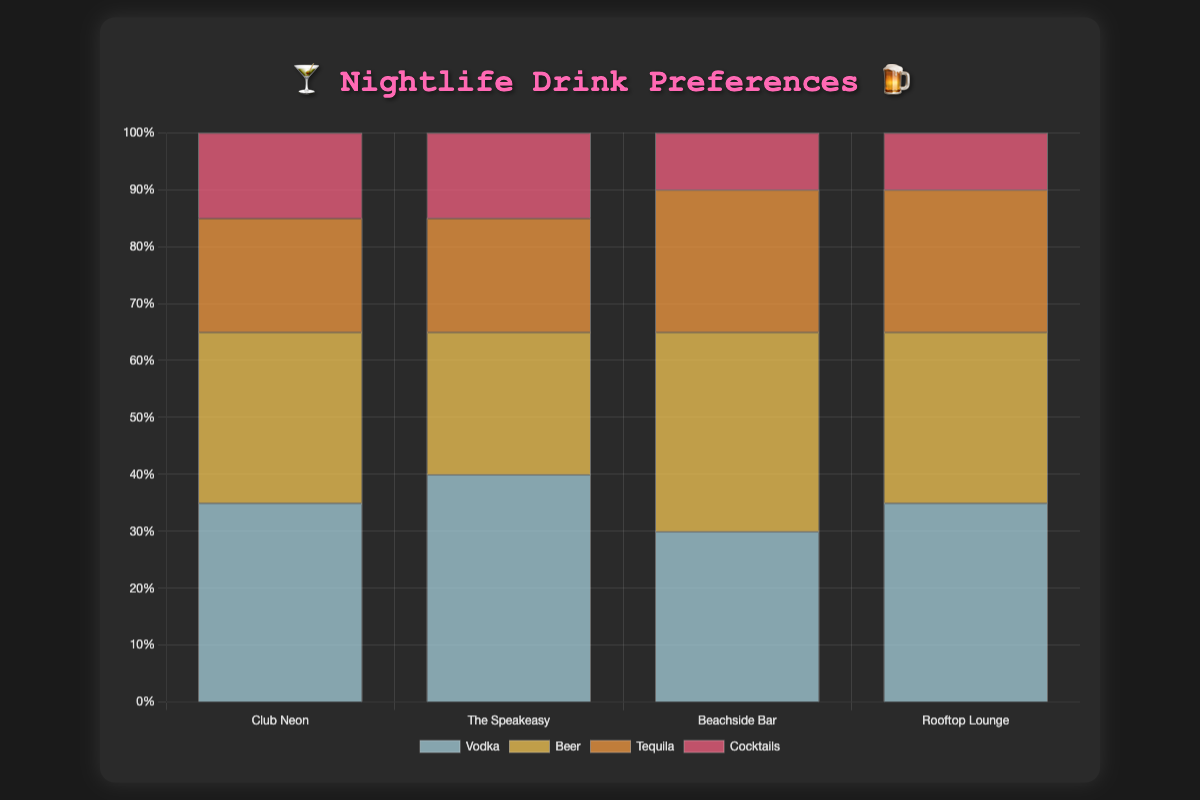What type of drink is most popular at Club Neon? At Club Neon, Vodka has the highest percentage with 35%. The figure shows the drink types and their corresponding percentages at each venue.
Answer: Vodka Which venue has the highest percentage of Whiskeys served? The Speakeasy serves the most Whiskeys with a percentage of 40%. The chart's data clearly shows the percentages for each type of drink at different venues.
Answer: The Speakeasy How much more Beer does the Beachside Bar serve compared to Club Neon? The Beachside Bar serves 35% Beer, while Club Neon serves 30%. The difference can be calculated as 35% - 30% = 5%.
Answer: 5% Which venue has a higher percentage of Craft Beer, and what is it? Comparing the venues, The Speakeasy serves 20% Craft Beer, and Beachside Bar serves none. Thus, The Speakeasy has a higher percentage.
Answer: The Speakeasy, 20% Calculate the average percentage of Cocktails served across all venues. The data for Cocktails across venues are: Club Neon (15%), Beachside Bar (25%), Rooftop Lounge (25%). The average can be calculated as (15% + 25% + 25%)/3 = 21.67%.
Answer: 21.67% At which venue is Champagne mostly served, and what's the percentage? Rooftop Lounge exclusively serves Champagne with a percentage of 35%, as shown by the chart.
Answer: Rooftop Lounge, 35% Which drink is least popular at Beachside Bar, and how does its percentage compare to other drinks there? At Beachside Bar, Tequila is the least popular with 10%. Comparing percentages, Beer (35%), Rum (30%), and Tropical Cocktails (25%) all have higher values.
Answer: Tequila, 10% If you combine all wine percentages from each venue, what is the total? Adding Wine percentages: The Speakeasy (15%), Rooftop Lounge (30%). Total = 15% + 30% = 45%.
Answer: 45% Which venue offers a wider variety of drinks based on the chart? All venues offer four types of drinks. Thus, no venue offers a wider variety than the others in terms of the number of drink types.
Answer: All venues offer the same variety Which type of drink has a greater presence overall, Beer or Cocktails? Summing the percentages across venues: Beer (Club Neon 30% + Beachside Bar 35% + The Speakeasy 20%) = 85%. Cocktails (Club Neon 15% + Beachside Bar 25% + Rooftop Lounge 25%) = 65%. Beer is more prevalent.
Answer: Beer What drink type stands out at The Speakeasy in terms of highest percentage? Whiskey is the standout drink at The Speakeasy, holding the highest percentage at 40%.
Answer: Whiskey 